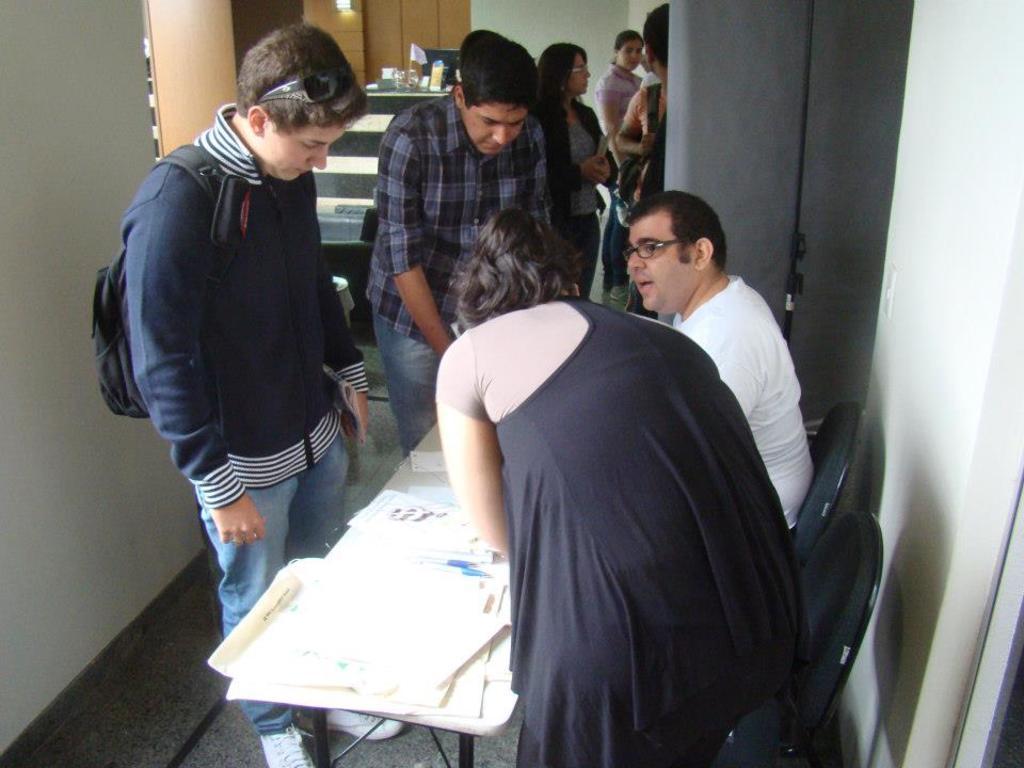In one or two sentences, can you explain what this image depicts? There are so many people standing in a room behind and there is a man sitting in a chair and woman standing bent and there is a table with some papers in it woman is writing something. 